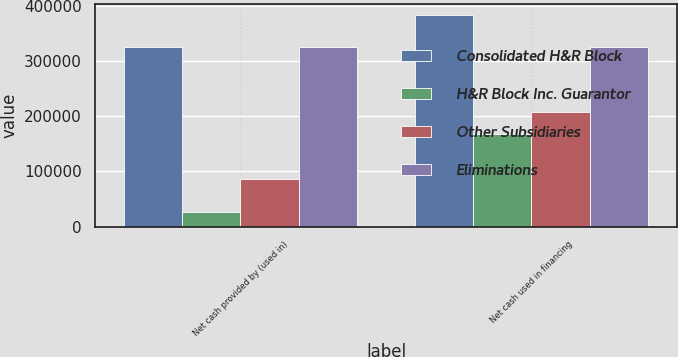Convert chart to OTSL. <chart><loc_0><loc_0><loc_500><loc_500><stacked_bar_chart><ecel><fcel>Net cash provided by (used in)<fcel>Net cash used in financing<nl><fcel>Consolidated H&R Block<fcel>324503<fcel>383430<nl><fcel>H&R Block Inc. Guarantor<fcel>26567<fcel>167738<nl><fcel>Other Subsidiaries<fcel>85600<fcel>207219<nl><fcel>Eliminations<fcel>324503<fcel>324503<nl></chart> 